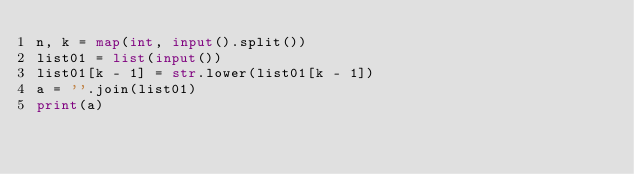<code> <loc_0><loc_0><loc_500><loc_500><_Python_>n, k = map(int, input().split())
list01 = list(input())
list01[k - 1] = str.lower(list01[k - 1])
a = ''.join(list01)
print(a)</code> 